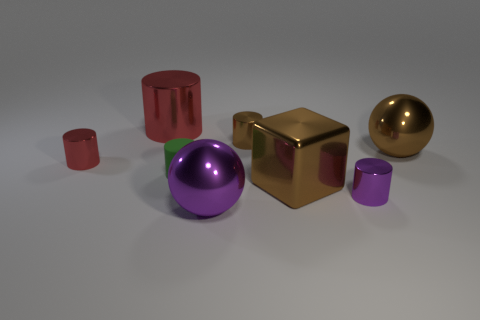Subtract 2 cylinders. How many cylinders are left? 3 Subtract all big cylinders. How many cylinders are left? 4 Subtract all green cylinders. How many cylinders are left? 4 Subtract all gray cylinders. Subtract all cyan blocks. How many cylinders are left? 5 Add 1 shiny cylinders. How many objects exist? 9 Subtract all cylinders. How many objects are left? 3 Subtract 0 blue cylinders. How many objects are left? 8 Subtract all big gray things. Subtract all large brown shiny spheres. How many objects are left? 7 Add 4 large metal spheres. How many large metal spheres are left? 6 Add 3 blue cylinders. How many blue cylinders exist? 3 